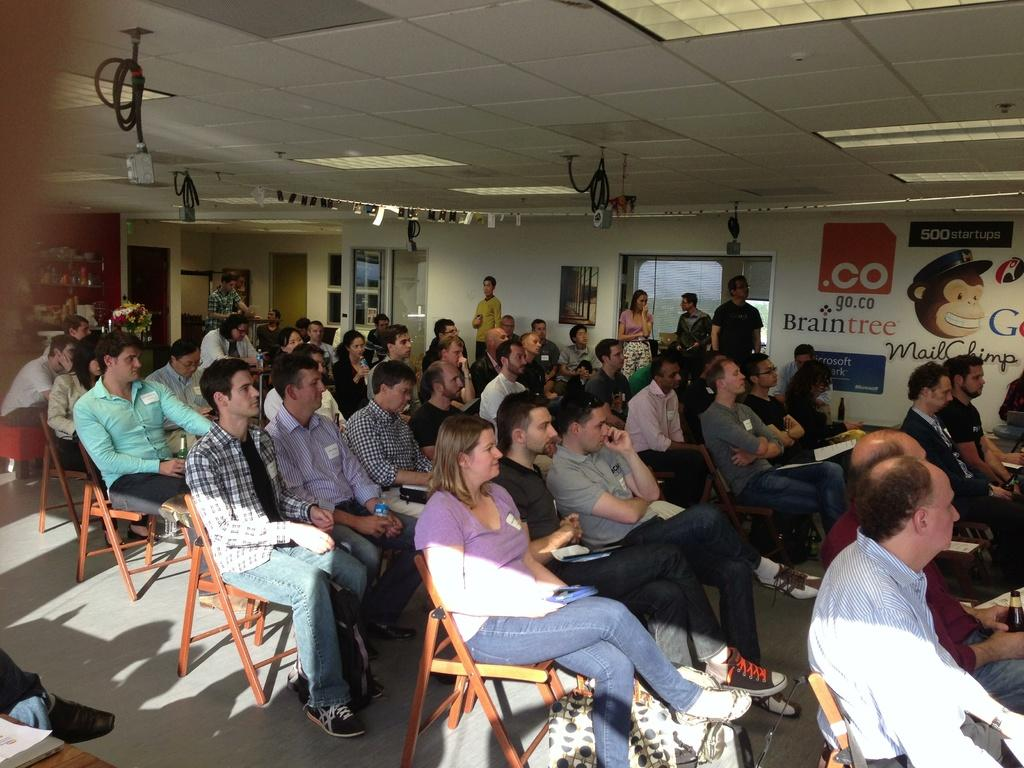What are the people in the image doing? The persons in the image are sitting on chairs. What can be seen beneath the people in the image? The floor is visible in the image. What is located behind the people in the image? There is a wall and a banner in the background of the image. Can you describe any architectural features in the image? Yes, there is a door in the image. What type of pie is being served to the achiever in the image? There is no pie or achiever present in the image. 